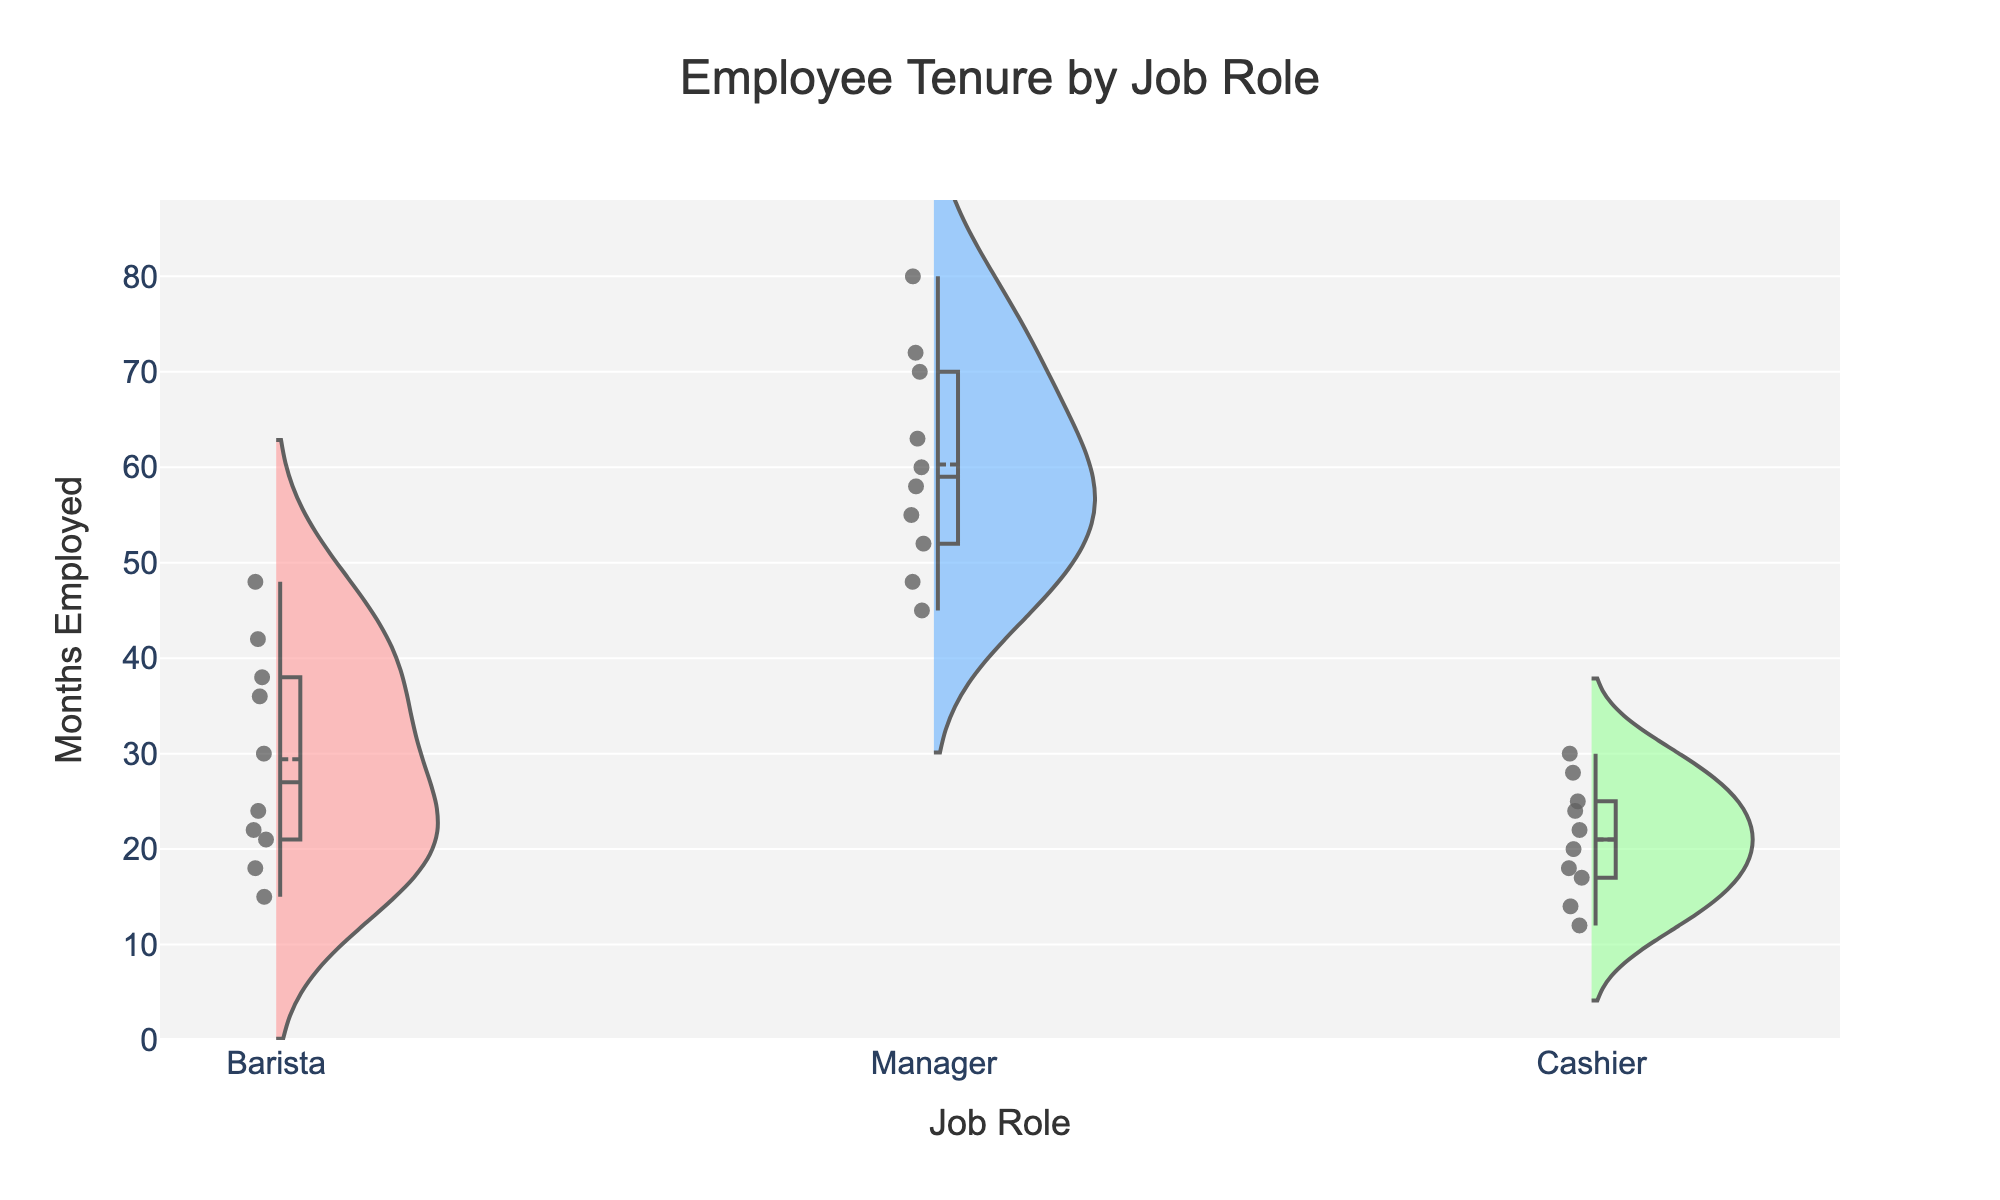Which job role has the highest median employee tenure? The violin plot with box plot overlay shows that the Manager role has the highest median employee tenure, as indicated by the central line inside the box plot portion of the Violin Chart being higher than that of Baristas and Cashiers.
Answer: Manager Which job role features the widest range of employee tenures? The Manager role shows the widest distribution in the violin plot, as it spans from 45 to around 80 months, whereas both Barista and Cashier roles have narrower distributions.
Answer: Manager What does the mean line indicate for the Barista group? The mean line visible in the violin plot for Baristas represents the average tenure of employees in that role. It is depicted as a horizontal line inside the plot.
Answer: The average tenure of Baristas Are there more experienced workers (longer tenures) in the Manager role compared to Cashier role? Yes, the Manager's violin plot extends to higher tenure values, indicating more experienced workers. The upper range for Managers is around 80 months, which is significantly higher than the upper tenure for Cashiers, which is around 30 months.
Answer: Yes How do the distributions of tenures for Baristas and Cashiers compare? The distribution for Baristas spans a wider range of months (15-48 months) compared to Cashiers (12-30 months) and has a higher median, indicated by both the violin plot and the box plot overlays.
Answer: Baristas show a wider range and higher median Which job role shows the least variability in employee tenure? The Cashier job role shows the least variability as indicated by the narrower spread and shorter length of the violin plot compared to Baristas and Managers.
Answer: Cashier What can be inferred about the employee retention strategy based on the Manager role's tenure distribution? The Manager role shows a high median and a broad range which implies successful retention strategies, possibly due to higher wages and experienced staff, as the tenure stretches up to 80 months.
Answer: Effective retention strategy How do the median tenures of Managers and Baristas compare? The median tenure for Managers is higher than that for Baristas, as observed from the central line in the box plot area of the violin chart. The median for Managers is around 60 months, while for Baristas, it is closer to 24 months.
Answer: Managers have a higher median tenure What does the presence of mean lines in the violin plot signify? The mean lines in the violin plots indicate the average tenure of employees within each job role, providing a central measure for understanding the distribution of tenures.
Answer: The average tenure of each job role 